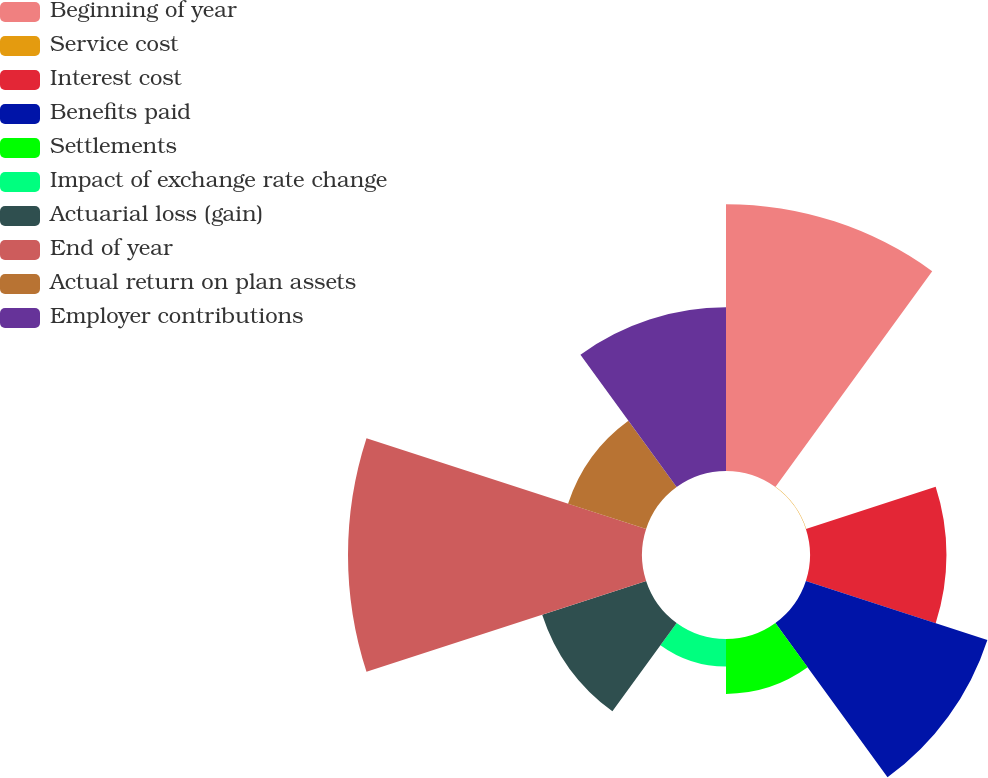<chart> <loc_0><loc_0><loc_500><loc_500><pie_chart><fcel>Beginning of year<fcel>Service cost<fcel>Interest cost<fcel>Benefits paid<fcel>Settlements<fcel>Impact of exchange rate change<fcel>Actuarial loss (gain)<fcel>End of year<fcel>Actual return on plan assets<fcel>Employer contributions<nl><fcel>20.12%<fcel>0.03%<fcel>10.29%<fcel>14.39%<fcel>4.14%<fcel>2.08%<fcel>8.24%<fcel>22.17%<fcel>6.19%<fcel>12.34%<nl></chart> 